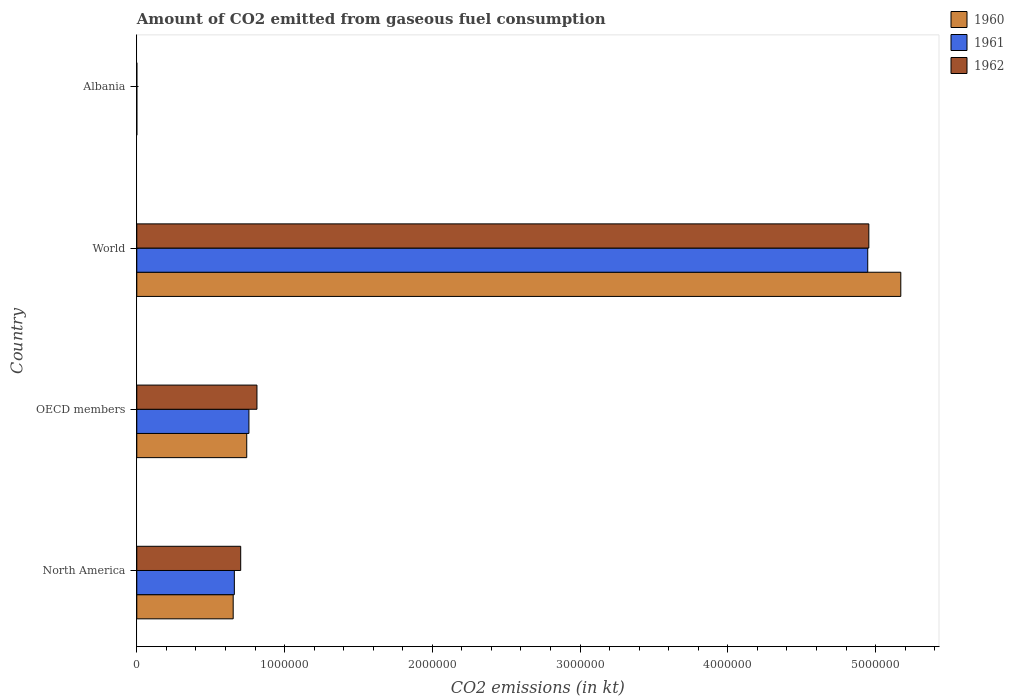How many groups of bars are there?
Your answer should be compact. 4. Are the number of bars per tick equal to the number of legend labels?
Make the answer very short. Yes. In how many cases, is the number of bars for a given country not equal to the number of legend labels?
Provide a succinct answer. 0. What is the amount of CO2 emitted in 1962 in OECD members?
Offer a very short reply. 8.13e+05. Across all countries, what is the maximum amount of CO2 emitted in 1962?
Your response must be concise. 4.95e+06. Across all countries, what is the minimum amount of CO2 emitted in 1960?
Ensure brevity in your answer.  84.34. In which country was the amount of CO2 emitted in 1961 maximum?
Your answer should be very brief. World. In which country was the amount of CO2 emitted in 1962 minimum?
Offer a very short reply. Albania. What is the total amount of CO2 emitted in 1962 in the graph?
Offer a terse response. 6.47e+06. What is the difference between the amount of CO2 emitted in 1960 in North America and that in World?
Your answer should be very brief. -4.52e+06. What is the difference between the amount of CO2 emitted in 1961 in Albania and the amount of CO2 emitted in 1960 in North America?
Provide a succinct answer. -6.52e+05. What is the average amount of CO2 emitted in 1962 per country?
Ensure brevity in your answer.  1.62e+06. What is the difference between the amount of CO2 emitted in 1961 and amount of CO2 emitted in 1960 in OECD members?
Give a very brief answer. 1.48e+04. In how many countries, is the amount of CO2 emitted in 1961 greater than 2600000 kt?
Provide a succinct answer. 1. What is the ratio of the amount of CO2 emitted in 1961 in North America to that in World?
Provide a short and direct response. 0.13. Is the difference between the amount of CO2 emitted in 1961 in OECD members and World greater than the difference between the amount of CO2 emitted in 1960 in OECD members and World?
Your answer should be compact. Yes. What is the difference between the highest and the second highest amount of CO2 emitted in 1960?
Give a very brief answer. 4.43e+06. What is the difference between the highest and the lowest amount of CO2 emitted in 1960?
Provide a short and direct response. 5.17e+06. What does the 1st bar from the top in North America represents?
Offer a very short reply. 1962. How many bars are there?
Make the answer very short. 12. Are all the bars in the graph horizontal?
Keep it short and to the point. Yes. What is the difference between two consecutive major ticks on the X-axis?
Make the answer very short. 1.00e+06. Does the graph contain grids?
Give a very brief answer. No. Where does the legend appear in the graph?
Make the answer very short. Top right. How many legend labels are there?
Offer a very short reply. 3. How are the legend labels stacked?
Offer a terse response. Vertical. What is the title of the graph?
Provide a succinct answer. Amount of CO2 emitted from gaseous fuel consumption. What is the label or title of the X-axis?
Provide a short and direct response. CO2 emissions (in kt). What is the CO2 emissions (in kt) in 1960 in North America?
Provide a short and direct response. 6.52e+05. What is the CO2 emissions (in kt) of 1961 in North America?
Your answer should be very brief. 6.60e+05. What is the CO2 emissions (in kt) of 1962 in North America?
Offer a terse response. 7.03e+05. What is the CO2 emissions (in kt) of 1960 in OECD members?
Provide a succinct answer. 7.44e+05. What is the CO2 emissions (in kt) of 1961 in OECD members?
Provide a short and direct response. 7.59e+05. What is the CO2 emissions (in kt) of 1962 in OECD members?
Your answer should be very brief. 8.13e+05. What is the CO2 emissions (in kt) of 1960 in World?
Give a very brief answer. 5.17e+06. What is the CO2 emissions (in kt) of 1961 in World?
Your answer should be very brief. 4.95e+06. What is the CO2 emissions (in kt) in 1962 in World?
Offer a terse response. 4.95e+06. What is the CO2 emissions (in kt) of 1960 in Albania?
Your answer should be compact. 84.34. What is the CO2 emissions (in kt) of 1961 in Albania?
Offer a terse response. 84.34. What is the CO2 emissions (in kt) in 1962 in Albania?
Give a very brief answer. 84.34. Across all countries, what is the maximum CO2 emissions (in kt) in 1960?
Your answer should be compact. 5.17e+06. Across all countries, what is the maximum CO2 emissions (in kt) in 1961?
Your response must be concise. 4.95e+06. Across all countries, what is the maximum CO2 emissions (in kt) in 1962?
Offer a terse response. 4.95e+06. Across all countries, what is the minimum CO2 emissions (in kt) of 1960?
Ensure brevity in your answer.  84.34. Across all countries, what is the minimum CO2 emissions (in kt) of 1961?
Make the answer very short. 84.34. Across all countries, what is the minimum CO2 emissions (in kt) in 1962?
Your answer should be very brief. 84.34. What is the total CO2 emissions (in kt) of 1960 in the graph?
Your answer should be compact. 6.57e+06. What is the total CO2 emissions (in kt) in 1961 in the graph?
Keep it short and to the point. 6.37e+06. What is the total CO2 emissions (in kt) in 1962 in the graph?
Ensure brevity in your answer.  6.47e+06. What is the difference between the CO2 emissions (in kt) in 1960 in North America and that in OECD members?
Offer a very short reply. -9.17e+04. What is the difference between the CO2 emissions (in kt) of 1961 in North America and that in OECD members?
Offer a terse response. -9.86e+04. What is the difference between the CO2 emissions (in kt) in 1962 in North America and that in OECD members?
Your answer should be compact. -1.10e+05. What is the difference between the CO2 emissions (in kt) in 1960 in North America and that in World?
Ensure brevity in your answer.  -4.52e+06. What is the difference between the CO2 emissions (in kt) of 1961 in North America and that in World?
Your answer should be very brief. -4.29e+06. What is the difference between the CO2 emissions (in kt) in 1962 in North America and that in World?
Keep it short and to the point. -4.25e+06. What is the difference between the CO2 emissions (in kt) of 1960 in North America and that in Albania?
Provide a short and direct response. 6.52e+05. What is the difference between the CO2 emissions (in kt) in 1961 in North America and that in Albania?
Make the answer very short. 6.60e+05. What is the difference between the CO2 emissions (in kt) of 1962 in North America and that in Albania?
Keep it short and to the point. 7.03e+05. What is the difference between the CO2 emissions (in kt) in 1960 in OECD members and that in World?
Your answer should be very brief. -4.43e+06. What is the difference between the CO2 emissions (in kt) of 1961 in OECD members and that in World?
Make the answer very short. -4.19e+06. What is the difference between the CO2 emissions (in kt) of 1962 in OECD members and that in World?
Make the answer very short. -4.14e+06. What is the difference between the CO2 emissions (in kt) of 1960 in OECD members and that in Albania?
Offer a terse response. 7.44e+05. What is the difference between the CO2 emissions (in kt) in 1961 in OECD members and that in Albania?
Your response must be concise. 7.59e+05. What is the difference between the CO2 emissions (in kt) in 1962 in OECD members and that in Albania?
Your response must be concise. 8.13e+05. What is the difference between the CO2 emissions (in kt) of 1960 in World and that in Albania?
Offer a very short reply. 5.17e+06. What is the difference between the CO2 emissions (in kt) of 1961 in World and that in Albania?
Provide a short and direct response. 4.95e+06. What is the difference between the CO2 emissions (in kt) of 1962 in World and that in Albania?
Keep it short and to the point. 4.95e+06. What is the difference between the CO2 emissions (in kt) of 1960 in North America and the CO2 emissions (in kt) of 1961 in OECD members?
Offer a terse response. -1.06e+05. What is the difference between the CO2 emissions (in kt) of 1960 in North America and the CO2 emissions (in kt) of 1962 in OECD members?
Your response must be concise. -1.61e+05. What is the difference between the CO2 emissions (in kt) of 1961 in North America and the CO2 emissions (in kt) of 1962 in OECD members?
Offer a very short reply. -1.53e+05. What is the difference between the CO2 emissions (in kt) of 1960 in North America and the CO2 emissions (in kt) of 1961 in World?
Give a very brief answer. -4.29e+06. What is the difference between the CO2 emissions (in kt) in 1960 in North America and the CO2 emissions (in kt) in 1962 in World?
Provide a short and direct response. -4.30e+06. What is the difference between the CO2 emissions (in kt) of 1961 in North America and the CO2 emissions (in kt) of 1962 in World?
Offer a very short reply. -4.29e+06. What is the difference between the CO2 emissions (in kt) in 1960 in North America and the CO2 emissions (in kt) in 1961 in Albania?
Keep it short and to the point. 6.52e+05. What is the difference between the CO2 emissions (in kt) of 1960 in North America and the CO2 emissions (in kt) of 1962 in Albania?
Offer a terse response. 6.52e+05. What is the difference between the CO2 emissions (in kt) in 1961 in North America and the CO2 emissions (in kt) in 1962 in Albania?
Make the answer very short. 6.60e+05. What is the difference between the CO2 emissions (in kt) of 1960 in OECD members and the CO2 emissions (in kt) of 1961 in World?
Offer a very short reply. -4.20e+06. What is the difference between the CO2 emissions (in kt) of 1960 in OECD members and the CO2 emissions (in kt) of 1962 in World?
Offer a very short reply. -4.21e+06. What is the difference between the CO2 emissions (in kt) in 1961 in OECD members and the CO2 emissions (in kt) in 1962 in World?
Make the answer very short. -4.20e+06. What is the difference between the CO2 emissions (in kt) in 1960 in OECD members and the CO2 emissions (in kt) in 1961 in Albania?
Your response must be concise. 7.44e+05. What is the difference between the CO2 emissions (in kt) in 1960 in OECD members and the CO2 emissions (in kt) in 1962 in Albania?
Your answer should be compact. 7.44e+05. What is the difference between the CO2 emissions (in kt) in 1961 in OECD members and the CO2 emissions (in kt) in 1962 in Albania?
Your answer should be compact. 7.59e+05. What is the difference between the CO2 emissions (in kt) of 1960 in World and the CO2 emissions (in kt) of 1961 in Albania?
Offer a terse response. 5.17e+06. What is the difference between the CO2 emissions (in kt) in 1960 in World and the CO2 emissions (in kt) in 1962 in Albania?
Offer a very short reply. 5.17e+06. What is the difference between the CO2 emissions (in kt) of 1961 in World and the CO2 emissions (in kt) of 1962 in Albania?
Your response must be concise. 4.95e+06. What is the average CO2 emissions (in kt) in 1960 per country?
Your answer should be compact. 1.64e+06. What is the average CO2 emissions (in kt) of 1961 per country?
Provide a short and direct response. 1.59e+06. What is the average CO2 emissions (in kt) in 1962 per country?
Ensure brevity in your answer.  1.62e+06. What is the difference between the CO2 emissions (in kt) in 1960 and CO2 emissions (in kt) in 1961 in North America?
Provide a succinct answer. -7828.66. What is the difference between the CO2 emissions (in kt) in 1960 and CO2 emissions (in kt) in 1962 in North America?
Ensure brevity in your answer.  -5.08e+04. What is the difference between the CO2 emissions (in kt) in 1961 and CO2 emissions (in kt) in 1962 in North America?
Provide a succinct answer. -4.30e+04. What is the difference between the CO2 emissions (in kt) of 1960 and CO2 emissions (in kt) of 1961 in OECD members?
Make the answer very short. -1.48e+04. What is the difference between the CO2 emissions (in kt) of 1960 and CO2 emissions (in kt) of 1962 in OECD members?
Provide a short and direct response. -6.92e+04. What is the difference between the CO2 emissions (in kt) in 1961 and CO2 emissions (in kt) in 1962 in OECD members?
Your answer should be very brief. -5.44e+04. What is the difference between the CO2 emissions (in kt) in 1960 and CO2 emissions (in kt) in 1961 in World?
Offer a very short reply. 2.24e+05. What is the difference between the CO2 emissions (in kt) of 1960 and CO2 emissions (in kt) of 1962 in World?
Your answer should be compact. 2.16e+05. What is the difference between the CO2 emissions (in kt) of 1961 and CO2 emissions (in kt) of 1962 in World?
Provide a succinct answer. -7334. What is the difference between the CO2 emissions (in kt) of 1960 and CO2 emissions (in kt) of 1961 in Albania?
Your answer should be very brief. 0. What is the difference between the CO2 emissions (in kt) of 1960 and CO2 emissions (in kt) of 1962 in Albania?
Your answer should be very brief. 0. What is the difference between the CO2 emissions (in kt) in 1961 and CO2 emissions (in kt) in 1962 in Albania?
Your answer should be very brief. 0. What is the ratio of the CO2 emissions (in kt) in 1960 in North America to that in OECD members?
Offer a terse response. 0.88. What is the ratio of the CO2 emissions (in kt) of 1961 in North America to that in OECD members?
Offer a very short reply. 0.87. What is the ratio of the CO2 emissions (in kt) in 1962 in North America to that in OECD members?
Ensure brevity in your answer.  0.86. What is the ratio of the CO2 emissions (in kt) in 1960 in North America to that in World?
Make the answer very short. 0.13. What is the ratio of the CO2 emissions (in kt) of 1961 in North America to that in World?
Keep it short and to the point. 0.13. What is the ratio of the CO2 emissions (in kt) in 1962 in North America to that in World?
Keep it short and to the point. 0.14. What is the ratio of the CO2 emissions (in kt) of 1960 in North America to that in Albania?
Your answer should be very brief. 7734.89. What is the ratio of the CO2 emissions (in kt) of 1961 in North America to that in Albania?
Your answer should be compact. 7827.72. What is the ratio of the CO2 emissions (in kt) of 1962 in North America to that in Albania?
Keep it short and to the point. 8337.76. What is the ratio of the CO2 emissions (in kt) in 1960 in OECD members to that in World?
Give a very brief answer. 0.14. What is the ratio of the CO2 emissions (in kt) of 1961 in OECD members to that in World?
Provide a short and direct response. 0.15. What is the ratio of the CO2 emissions (in kt) in 1962 in OECD members to that in World?
Your response must be concise. 0.16. What is the ratio of the CO2 emissions (in kt) in 1960 in OECD members to that in Albania?
Provide a short and direct response. 8821.78. What is the ratio of the CO2 emissions (in kt) of 1961 in OECD members to that in Albania?
Your answer should be compact. 8997.23. What is the ratio of the CO2 emissions (in kt) in 1962 in OECD members to that in Albania?
Keep it short and to the point. 9641.88. What is the ratio of the CO2 emissions (in kt) of 1960 in World to that in Albania?
Your response must be concise. 6.13e+04. What is the ratio of the CO2 emissions (in kt) of 1961 in World to that in Albania?
Your response must be concise. 5.87e+04. What is the ratio of the CO2 emissions (in kt) in 1962 in World to that in Albania?
Ensure brevity in your answer.  5.87e+04. What is the difference between the highest and the second highest CO2 emissions (in kt) of 1960?
Your response must be concise. 4.43e+06. What is the difference between the highest and the second highest CO2 emissions (in kt) of 1961?
Your answer should be very brief. 4.19e+06. What is the difference between the highest and the second highest CO2 emissions (in kt) in 1962?
Ensure brevity in your answer.  4.14e+06. What is the difference between the highest and the lowest CO2 emissions (in kt) of 1960?
Provide a succinct answer. 5.17e+06. What is the difference between the highest and the lowest CO2 emissions (in kt) in 1961?
Offer a terse response. 4.95e+06. What is the difference between the highest and the lowest CO2 emissions (in kt) of 1962?
Your response must be concise. 4.95e+06. 